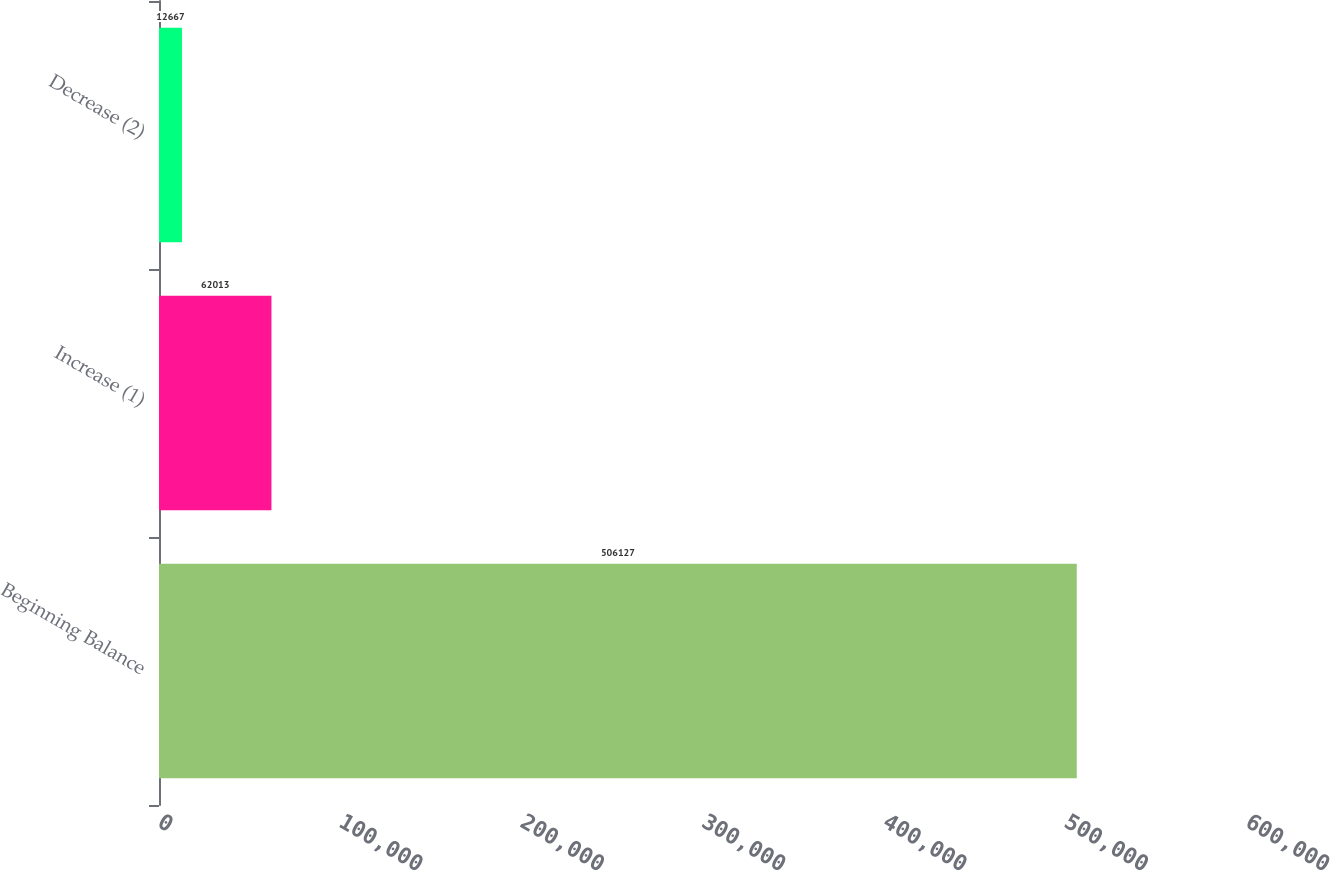<chart> <loc_0><loc_0><loc_500><loc_500><bar_chart><fcel>Beginning Balance<fcel>Increase (1)<fcel>Decrease (2)<nl><fcel>506127<fcel>62013<fcel>12667<nl></chart> 